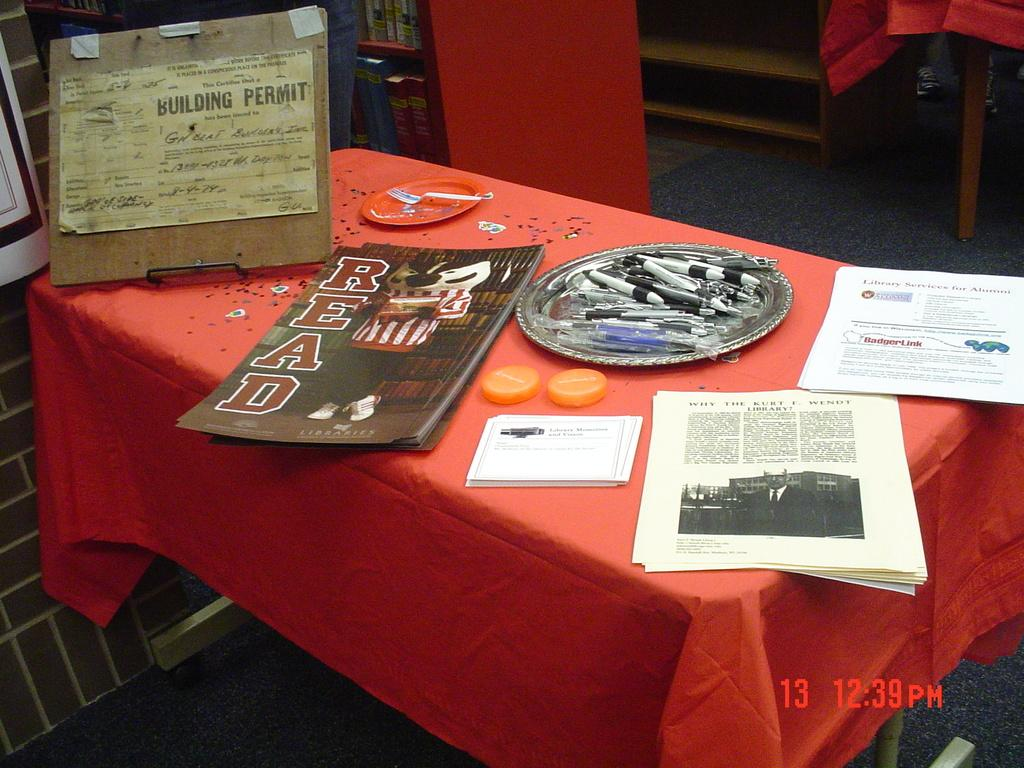<image>
Write a terse but informative summary of the picture. A table of various papers including a building permit and a folder that says read. 